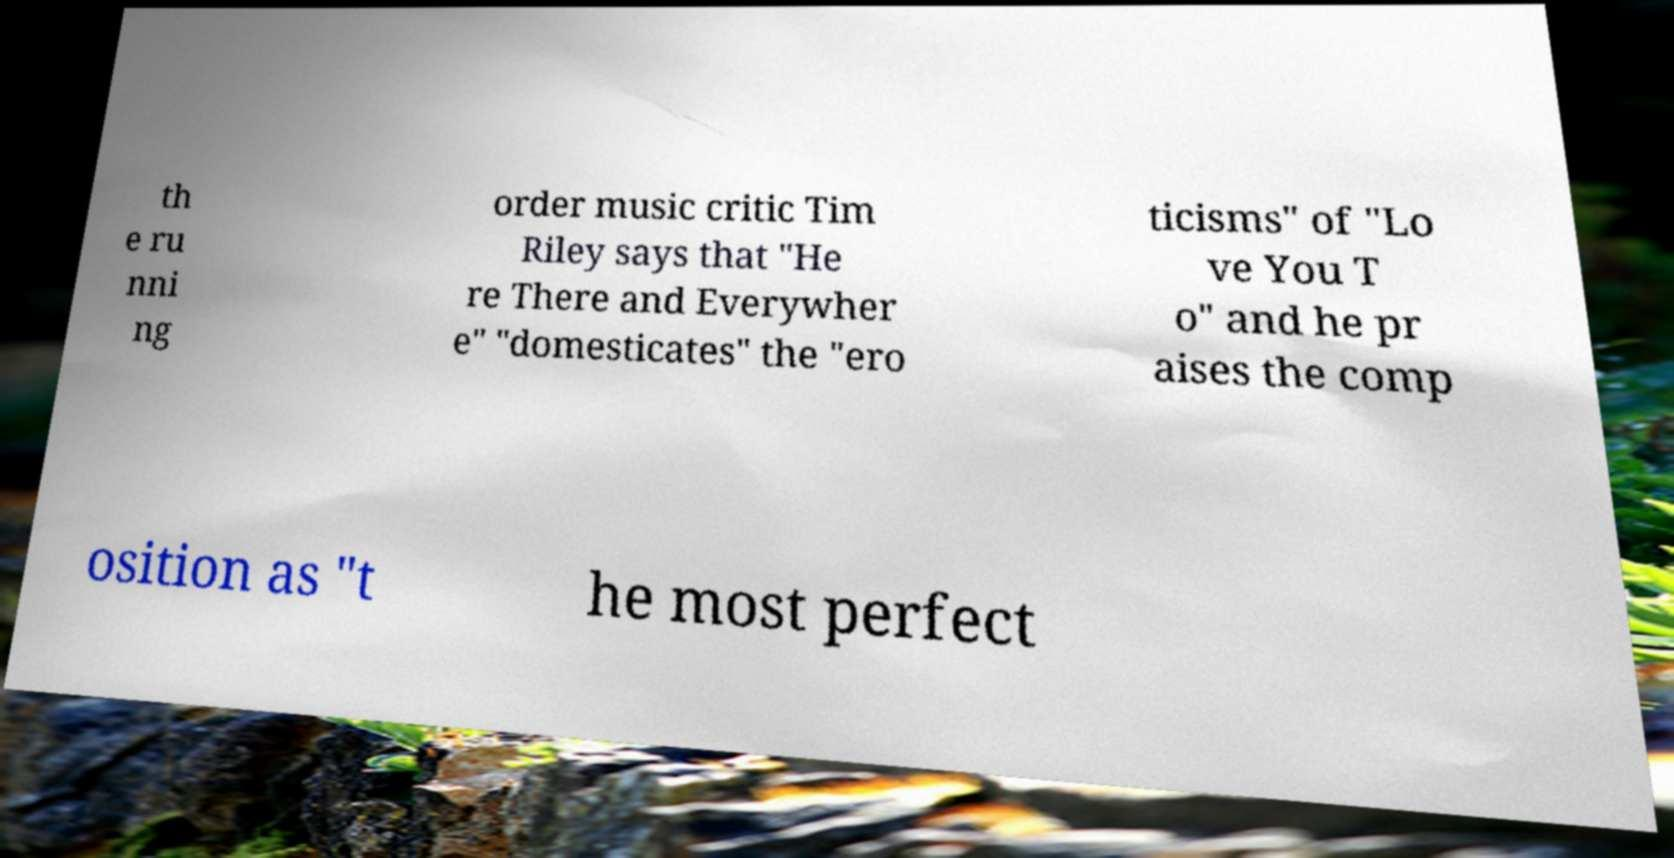There's text embedded in this image that I need extracted. Can you transcribe it verbatim? th e ru nni ng order music critic Tim Riley says that "He re There and Everywher e" "domesticates" the "ero ticisms" of "Lo ve You T o" and he pr aises the comp osition as "t he most perfect 